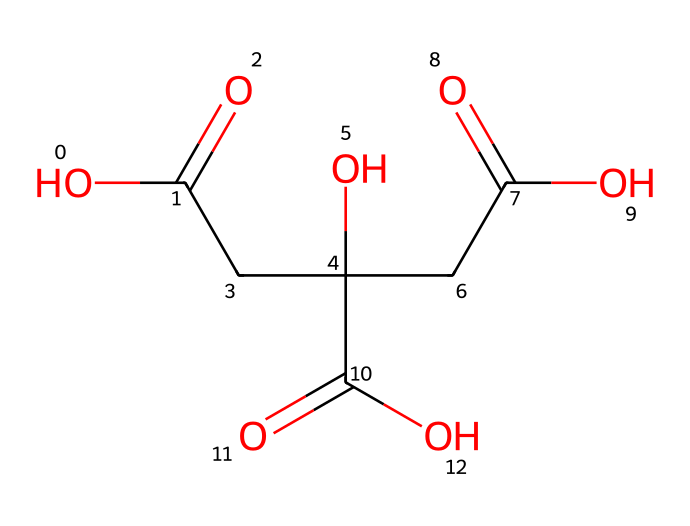What is the name of the chemical represented by this SMILES? The SMILES notation represents citric acid, which is a tricarboxylic acid commonly found in citrus fruits.
Answer: citric acid How many carbon atoms are present in this molecule? By analyzing the SMILES, we can count the carbon atoms (C). There are 6 carbon atoms in citric acid.
Answer: 6 What functional groups can be identified in this chemical structure? This chemical has three carboxylic acid functional groups (-COOH) evident from the presence of the carbonyl (C=O) and hydroxyl (OH) parts in the structure.
Answer: carboxylic acid What effect does citric acid have when combined with baking soda? Citric acid reacts with baking soda (sodium bicarbonate) to produce carbon dioxide gas, leading to fizzing or bubbling behavior in sensory play experiences.
Answer: fizzing How many double bonds are there in the structure of citric acid? In the SMILES representation, there are three double bonds associated with the carbonyl groups of the carboxylic acid functional groups.
Answer: 3 What is a key sensory experience created by citric acid in combination with other ingredients? When citric acid is mixed with substances like baking soda, it generates carbon dioxide gas bubbles that create a fizzy sensation, enhancing tactile feedback during play.
Answer: fizzy sensation 